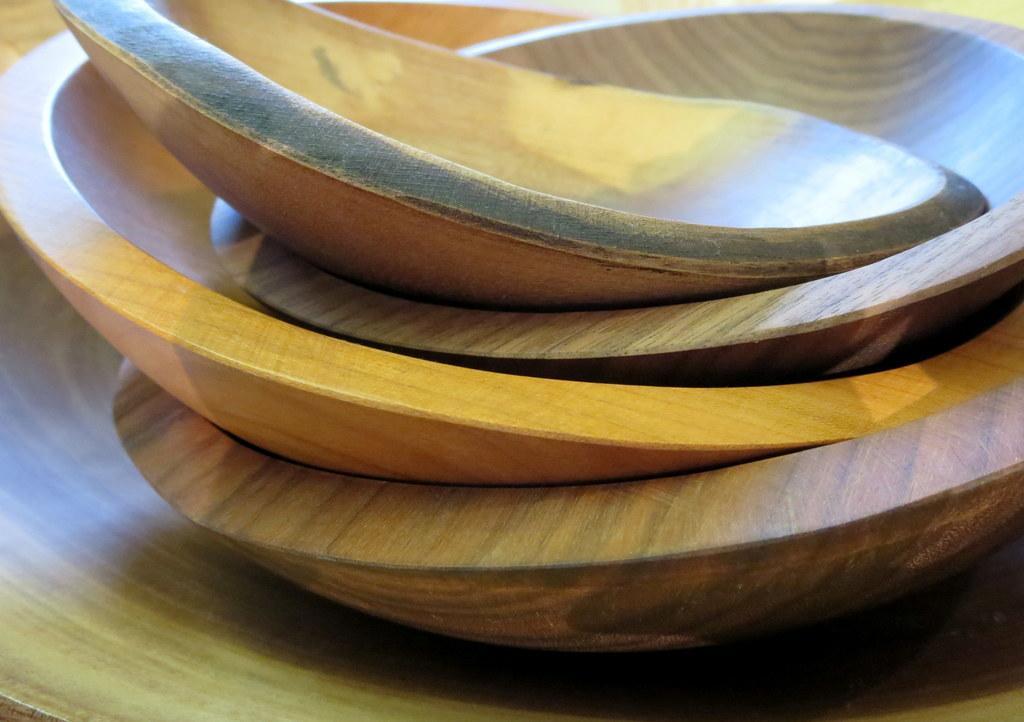Could you give a brief overview of what you see in this image? In the picture we can see a wooden plank on it we can see a wooden bowls one on the other. 